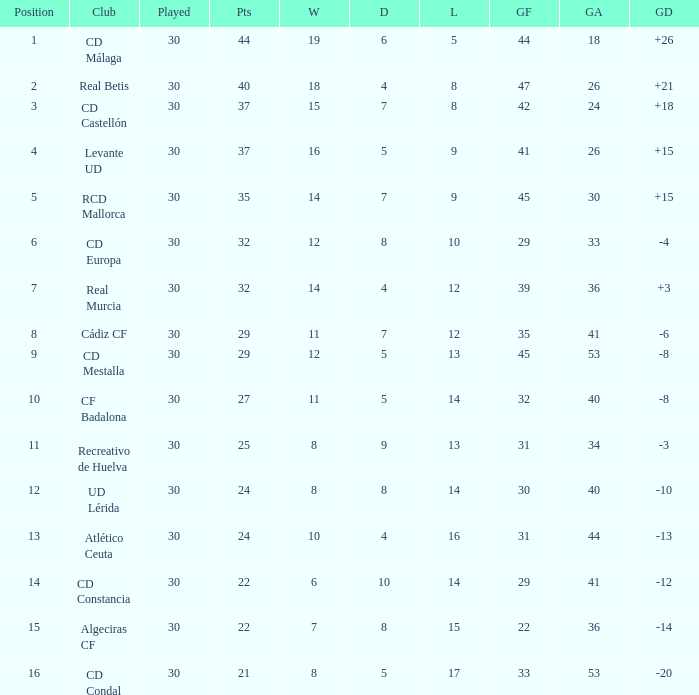What is the wins number when the points were smaller than 27, and goals against was 41? 6.0. 